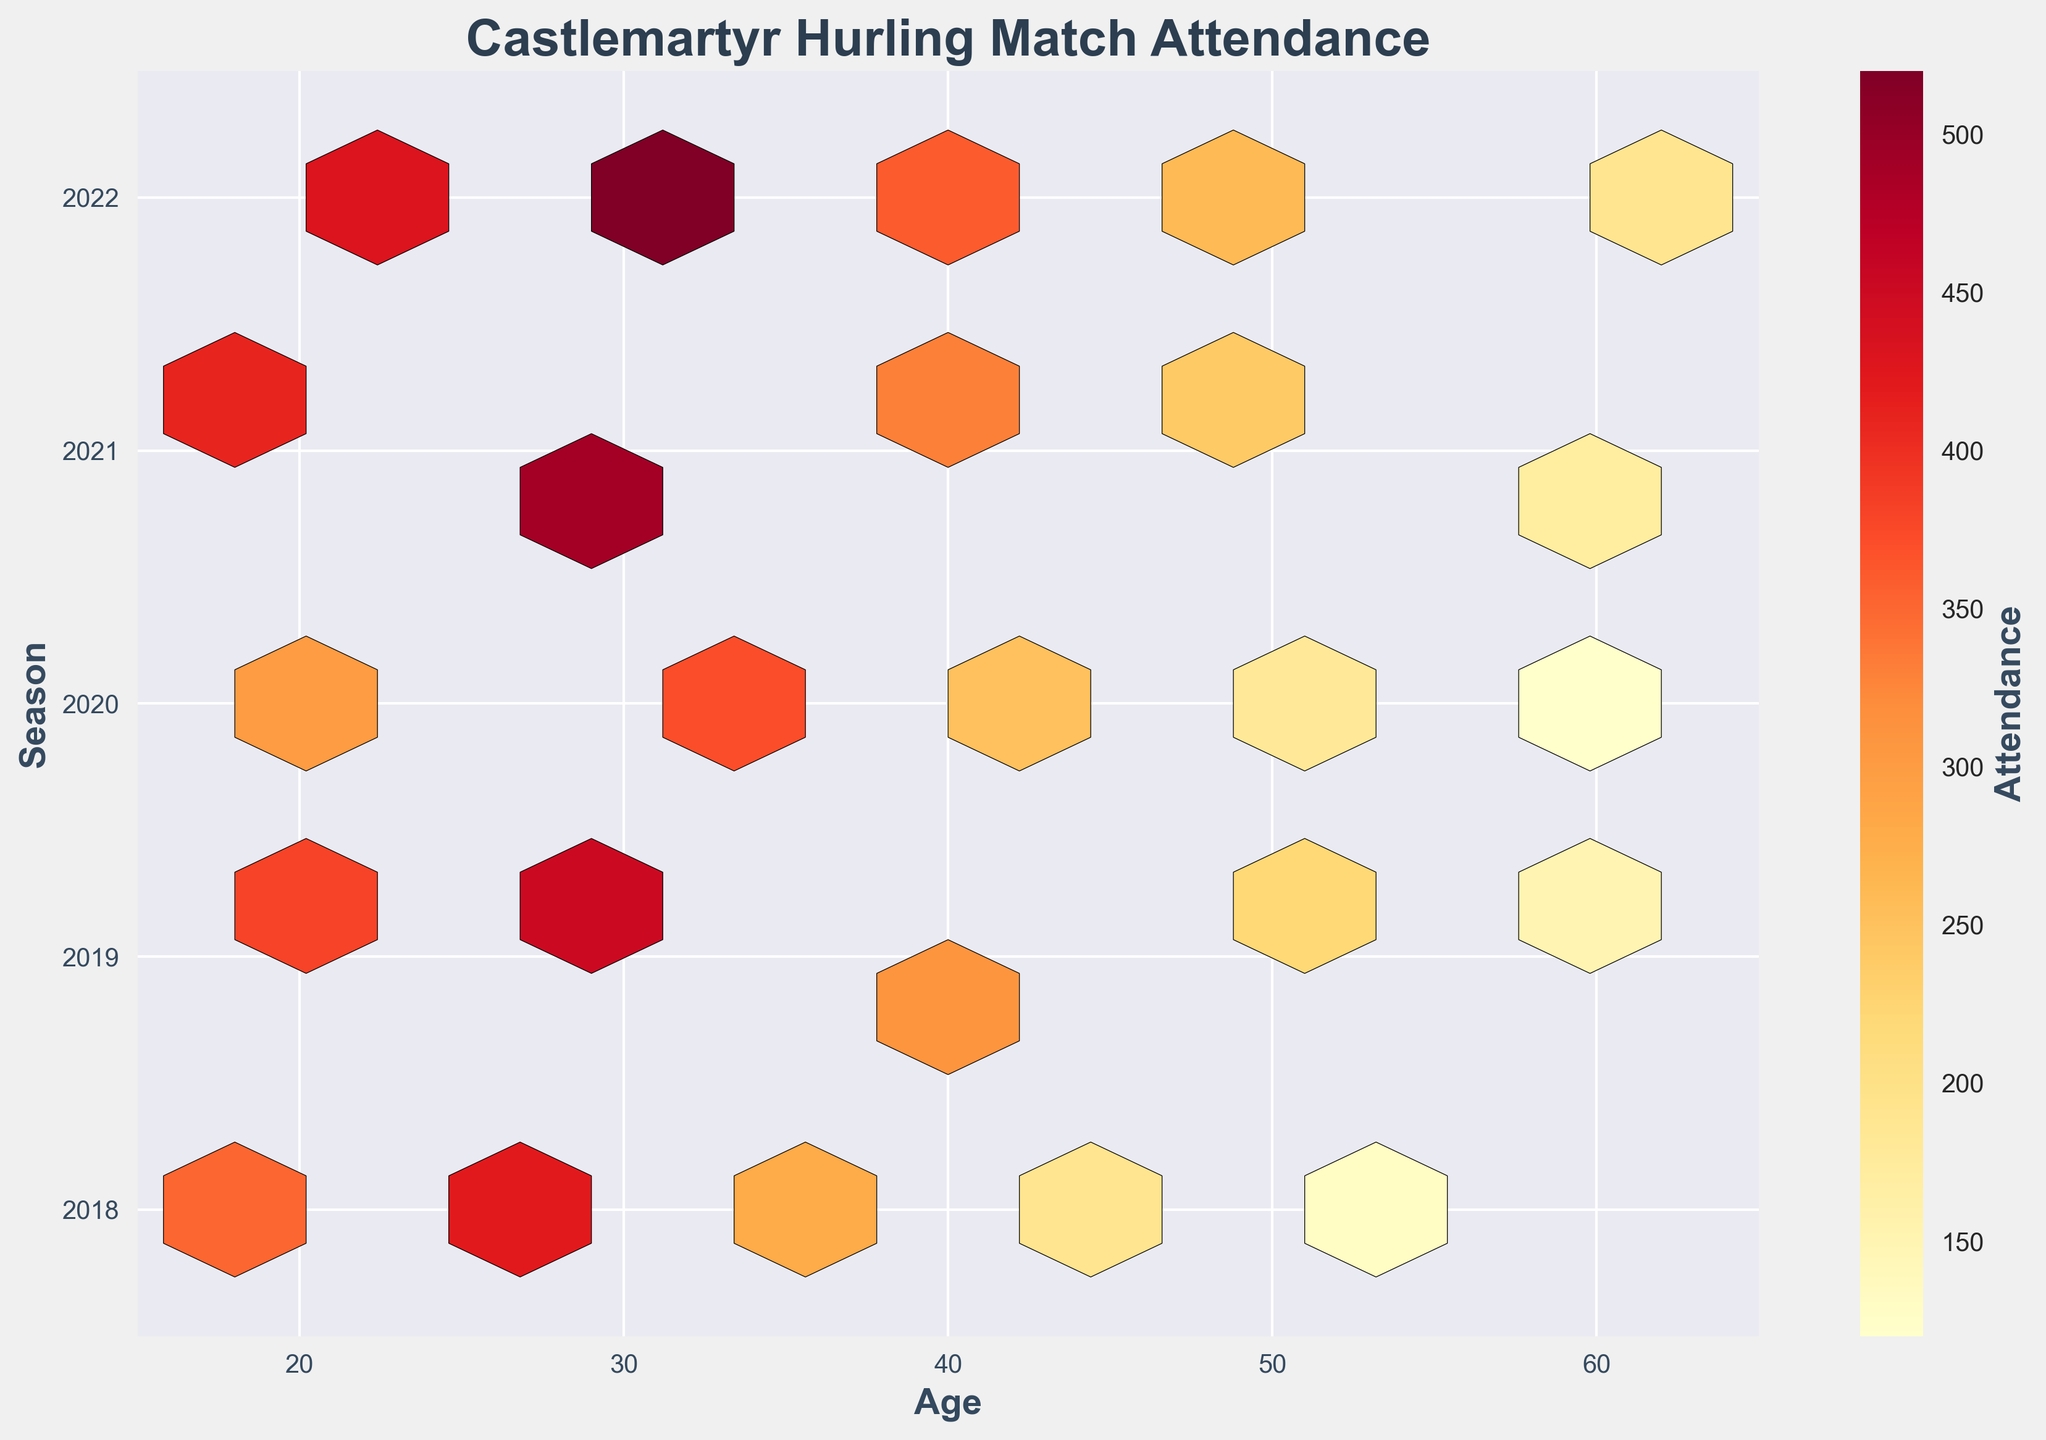What's the title of the plot? The title is located at the top of the plot in bold and larger text. It provides a quick summary of what the plot is about.
Answer: Castlemartyr Hurling Match Attendance What are the labels for the X and Y axes? The X-axis label is located at the bottom of the horizontal axis, and the Y-axis label is positioned on the left vertical axis. They help to understand what variables are being plotted.
Answer: Age (X-axis), Season (Y-axis) Which color represents the highest attendance in the hexbin plot color scheme? The hexbin plot uses a color gradient from light to dark. The darkest color usually represents the highest value.
Answer: Darkest red In which season is there a notable increase in attendance for the age group of around 30? By observing the density of the darker hex bins around the age of 30 across different seasons, we can identify the season with the most significant increase.
Answer: 2022 Which season shows the least attendance in almost all age groups? Look for the season where the hex bins are lighter or less dense across the entire age range.
Answer: 2020 What age group has the highest attendance in the 2022 season? Identify the hexbin with the darkest color within the 2022 season row, then check the corresponding age group on the X-axis.
Answer: Around 31 Compare the attendance in the 2018 and 2021 seasons for the 40-year-old age group. Which season had higher attendance? Check the color intensity of the hexbin at age 40 for the years 2018 and 2021. The darker hexbin indicates higher attendance.
Answer: 2021 What's the general trend of attendance across different age groups from 2018 to 2022? Examine the color evolution of hexbins across seasons for different age groups to identify any obvious trends or patterns.
Answer: Increasing with peaks around age 30 Which two age groups have the closest attendance numbers in the 2019 season? Find the hex bins in the 2019 row with the closest color intensity and check their corresponding ages on the X-axis.
Answer: Ages 20 and 25 Identify any outliers in attendance within the plot. Look for any particularly dark or light hex bins that stand out sharply from others within their respective season.
Answer: Age 31 in 2022 